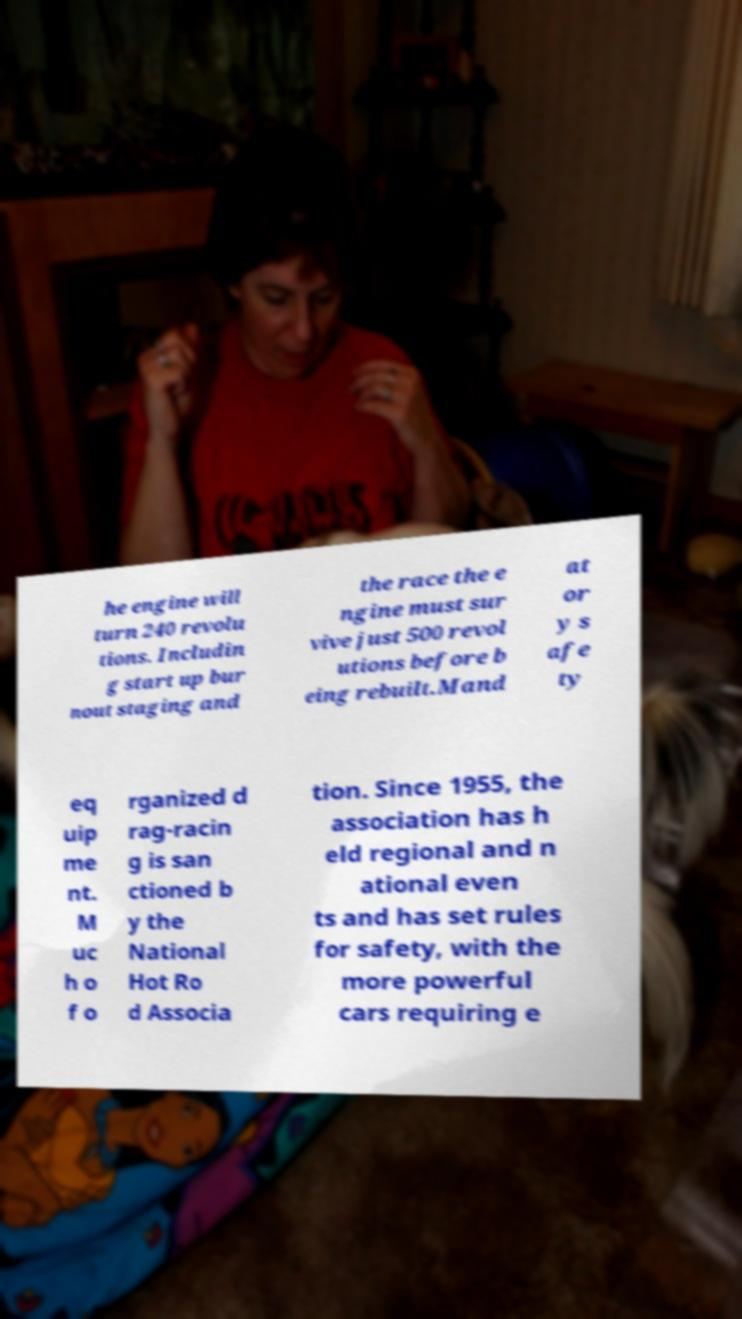Could you assist in decoding the text presented in this image and type it out clearly? he engine will turn 240 revolu tions. Includin g start up bur nout staging and the race the e ngine must sur vive just 500 revol utions before b eing rebuilt.Mand at or y s afe ty eq uip me nt. M uc h o f o rganized d rag-racin g is san ctioned b y the National Hot Ro d Associa tion. Since 1955, the association has h eld regional and n ational even ts and has set rules for safety, with the more powerful cars requiring e 